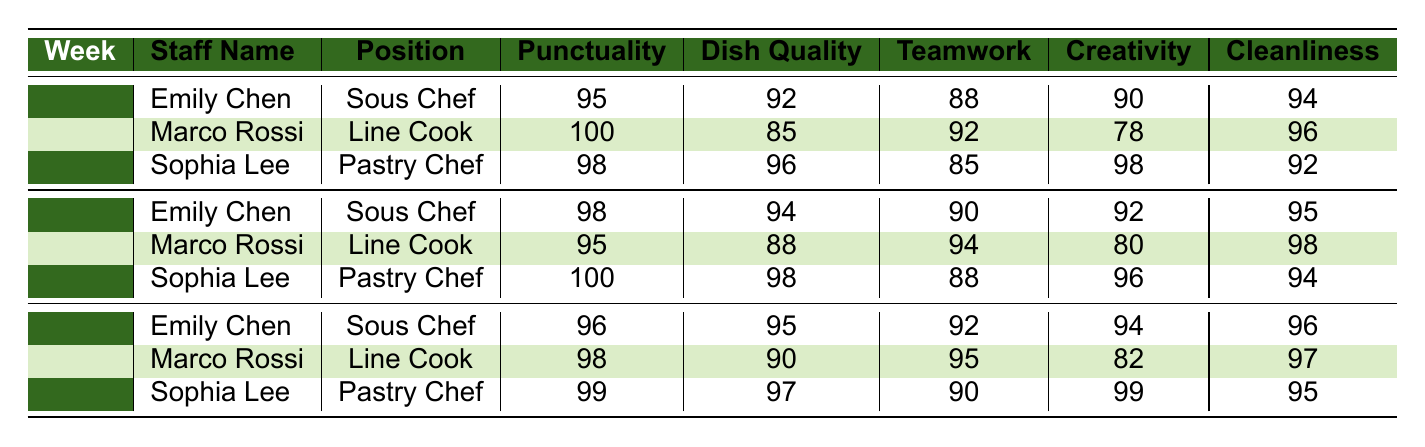What is the Dish Quality score for Sophia Lee in Week 2? In Week 2, the table shows that Sophia Lee's Dish Quality score is 98.
Answer: 98 Which staff member had the highest Punctuality score in Week 1? The table indicates that Marco Rossi had the highest Punctuality score of 100 in Week 1.
Answer: Marco Rossi What is the average Cleanliness score for Emily Chen over the three weeks? Emily Chen's Cleanliness scores are 94, 95, and 96. Summing these gives 94 + 95 + 96 = 285, and dividing by 3 gives an average of 285 / 3 = 95.
Answer: 95 Did Sophia Lee improve her Dish Quality score from Week 1 to Week 3? In Week 1, Sophia Lee's Dish Quality score was 96, and in Week 3, it increased to 97, indicating an improvement.
Answer: Yes What was Marco Rossi's average Teamwork score across the three weeks? Marco Rossi's Teamwork scores are 92, 94, and 95. Adding these gives 92 + 94 + 95 = 281, and dividing by 3 gives an average of 281 / 3 = approximately 93.67.
Answer: 93.67 In which week did Emily Chen achieve her highest Dish Quality score? Upon reviewing the scores, Emily Chen's Dish Quality scores are 92 (Week 1), 94 (Week 2), and 95 (Week 3). Her highest score is 95 in Week 3.
Answer: Week 3 What is the difference in Creativity scores for Sophia Lee between Week 1 and Week 2? Sophia Lee had a Creativity score of 98 in Week 1 and 96 in Week 2. The difference is 98 - 96 = 2.
Answer: 2 Which position had the lowest average Punctuality score among all staff members? Punctuality scores for each staff are: Emily Chen: 95, 98, 96; Marco Rossi: 100, 95, 98; Sophia Lee: 98, 100, 99. The averages are: Emily Chen: 96.33, Marco Rossi: 97.67, Sophia Lee: 99. The lowest average is for Emily Chen with 96.33.
Answer: Sous Chef How many times did Marco Rossi score below 90 for Dish Quality? Marco Rossi's Dish Quality scores are 85 (Week 1), 88 (Week 2), and 90 (Week 3). He scored below 90 twice in total (Week 1 and Week 2).
Answer: 2 Did any staff member receive a perfect score in any category during Week 2? Upon checking the scores in Week 2, Marco Rossi achieved a perfect score of 100 in Punctuality, indicating he received a perfect score.
Answer: Yes What was the highest Cleanliness score achieved by any staff member in Week 3? In Week 3, the Cleanliness scores are Emily Chen: 96, Marco Rossi: 97, and Sophia Lee: 95. The highest is Marco Rossi with 97.
Answer: 97 